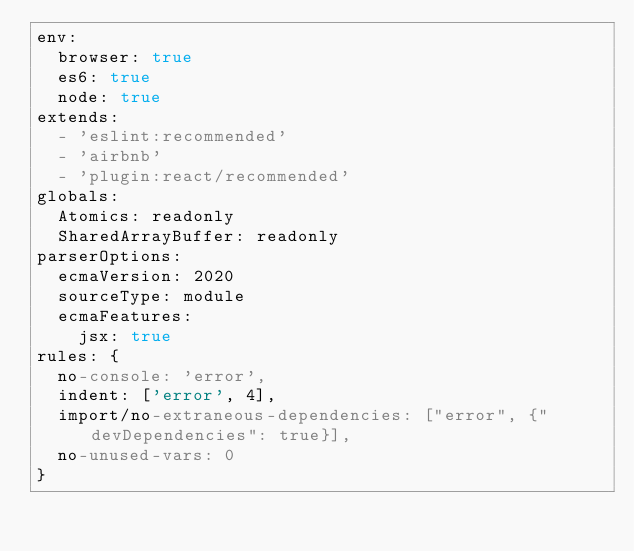Convert code to text. <code><loc_0><loc_0><loc_500><loc_500><_YAML_>env:
  browser: true
  es6: true
  node: true
extends:
  - 'eslint:recommended'
  - 'airbnb'
  - 'plugin:react/recommended'
globals:
  Atomics: readonly
  SharedArrayBuffer: readonly
parserOptions:
  ecmaVersion: 2020
  sourceType: module
  ecmaFeatures:
    jsx: true
rules: {
  no-console: 'error',
  indent: ['error', 4],
  import/no-extraneous-dependencies: ["error", {"devDependencies": true}],
  no-unused-vars: 0
}
</code> 